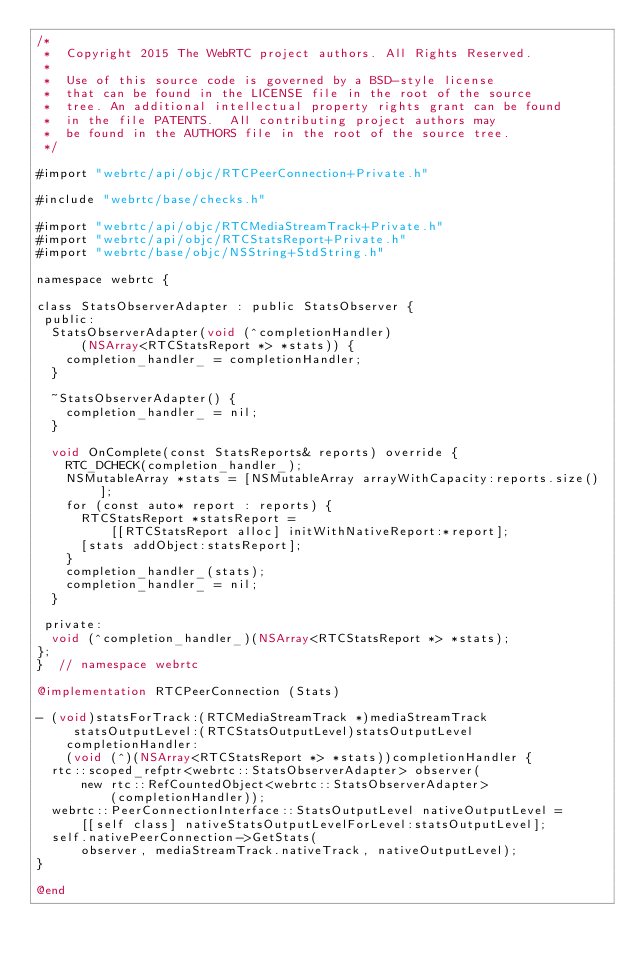<code> <loc_0><loc_0><loc_500><loc_500><_ObjectiveC_>/*
 *  Copyright 2015 The WebRTC project authors. All Rights Reserved.
 *
 *  Use of this source code is governed by a BSD-style license
 *  that can be found in the LICENSE file in the root of the source
 *  tree. An additional intellectual property rights grant can be found
 *  in the file PATENTS.  All contributing project authors may
 *  be found in the AUTHORS file in the root of the source tree.
 */

#import "webrtc/api/objc/RTCPeerConnection+Private.h"

#include "webrtc/base/checks.h"

#import "webrtc/api/objc/RTCMediaStreamTrack+Private.h"
#import "webrtc/api/objc/RTCStatsReport+Private.h"
#import "webrtc/base/objc/NSString+StdString.h"

namespace webrtc {

class StatsObserverAdapter : public StatsObserver {
 public:
  StatsObserverAdapter(void (^completionHandler)
      (NSArray<RTCStatsReport *> *stats)) {
    completion_handler_ = completionHandler;
  }

  ~StatsObserverAdapter() {
    completion_handler_ = nil;
  }

  void OnComplete(const StatsReports& reports) override {
    RTC_DCHECK(completion_handler_);
    NSMutableArray *stats = [NSMutableArray arrayWithCapacity:reports.size()];
    for (const auto* report : reports) {
      RTCStatsReport *statsReport =
          [[RTCStatsReport alloc] initWithNativeReport:*report];
      [stats addObject:statsReport];
    }
    completion_handler_(stats);
    completion_handler_ = nil;
  }

 private:
  void (^completion_handler_)(NSArray<RTCStatsReport *> *stats);
};
}  // namespace webrtc

@implementation RTCPeerConnection (Stats)

- (void)statsForTrack:(RTCMediaStreamTrack *)mediaStreamTrack
     statsOutputLevel:(RTCStatsOutputLevel)statsOutputLevel
    completionHandler:
    (void (^)(NSArray<RTCStatsReport *> *stats))completionHandler {
  rtc::scoped_refptr<webrtc::StatsObserverAdapter> observer(
      new rtc::RefCountedObject<webrtc::StatsObserverAdapter>
          (completionHandler));
  webrtc::PeerConnectionInterface::StatsOutputLevel nativeOutputLevel =
      [[self class] nativeStatsOutputLevelForLevel:statsOutputLevel];
  self.nativePeerConnection->GetStats(
      observer, mediaStreamTrack.nativeTrack, nativeOutputLevel);
}

@end
</code> 